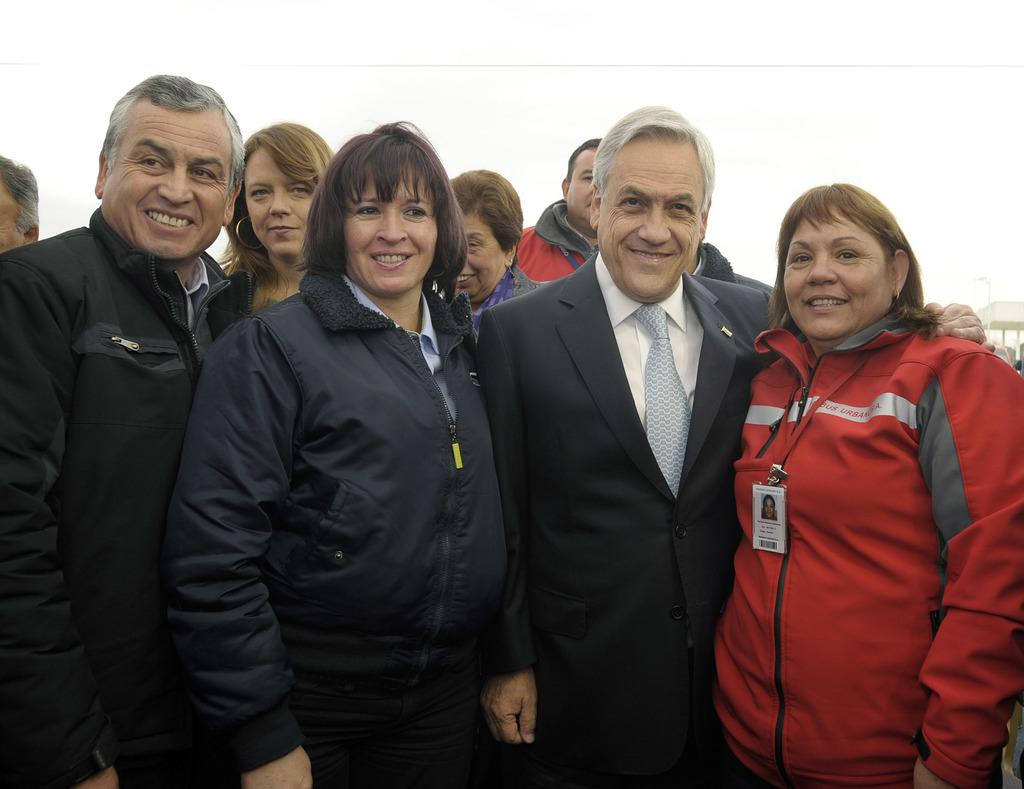What is happening in the image involving the people? The people in the image are standing and smiling. Can you describe the attire of one of the individuals in the image? There is a man wearing a suit in the image. What can be seen in the background of the image? The sky is visible at the top of the image. What type of fold can be seen in the man's suit in the image? There is no fold visible in the man's suit in the image. What is the competition that the people are participating in within the image? There is no competition depicted in the image; the people are standing and smiling. 